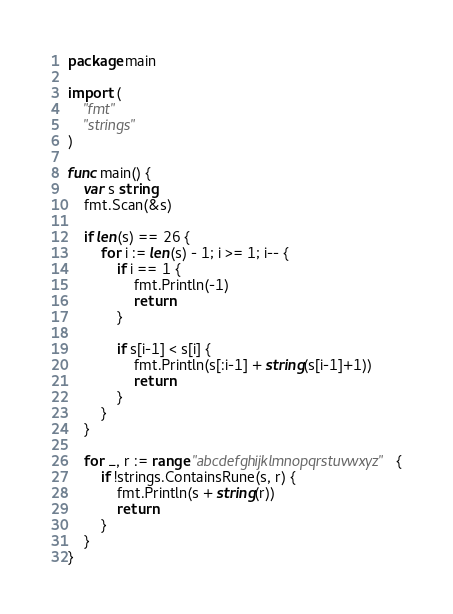<code> <loc_0><loc_0><loc_500><loc_500><_Go_>package main

import (
	"fmt"
	"strings"
)

func main() {
	var s string
	fmt.Scan(&s)

	if len(s) == 26 {
		for i := len(s) - 1; i >= 1; i-- {
			if i == 1 {
				fmt.Println(-1)
				return
			}

			if s[i-1] < s[i] {
				fmt.Println(s[:i-1] + string(s[i-1]+1))
				return
			}
		}
	}

	for _, r := range "abcdefghijklmnopqrstuvwxyz" {
		if !strings.ContainsRune(s, r) {
			fmt.Println(s + string(r))
			return
		}
	}
}
</code> 